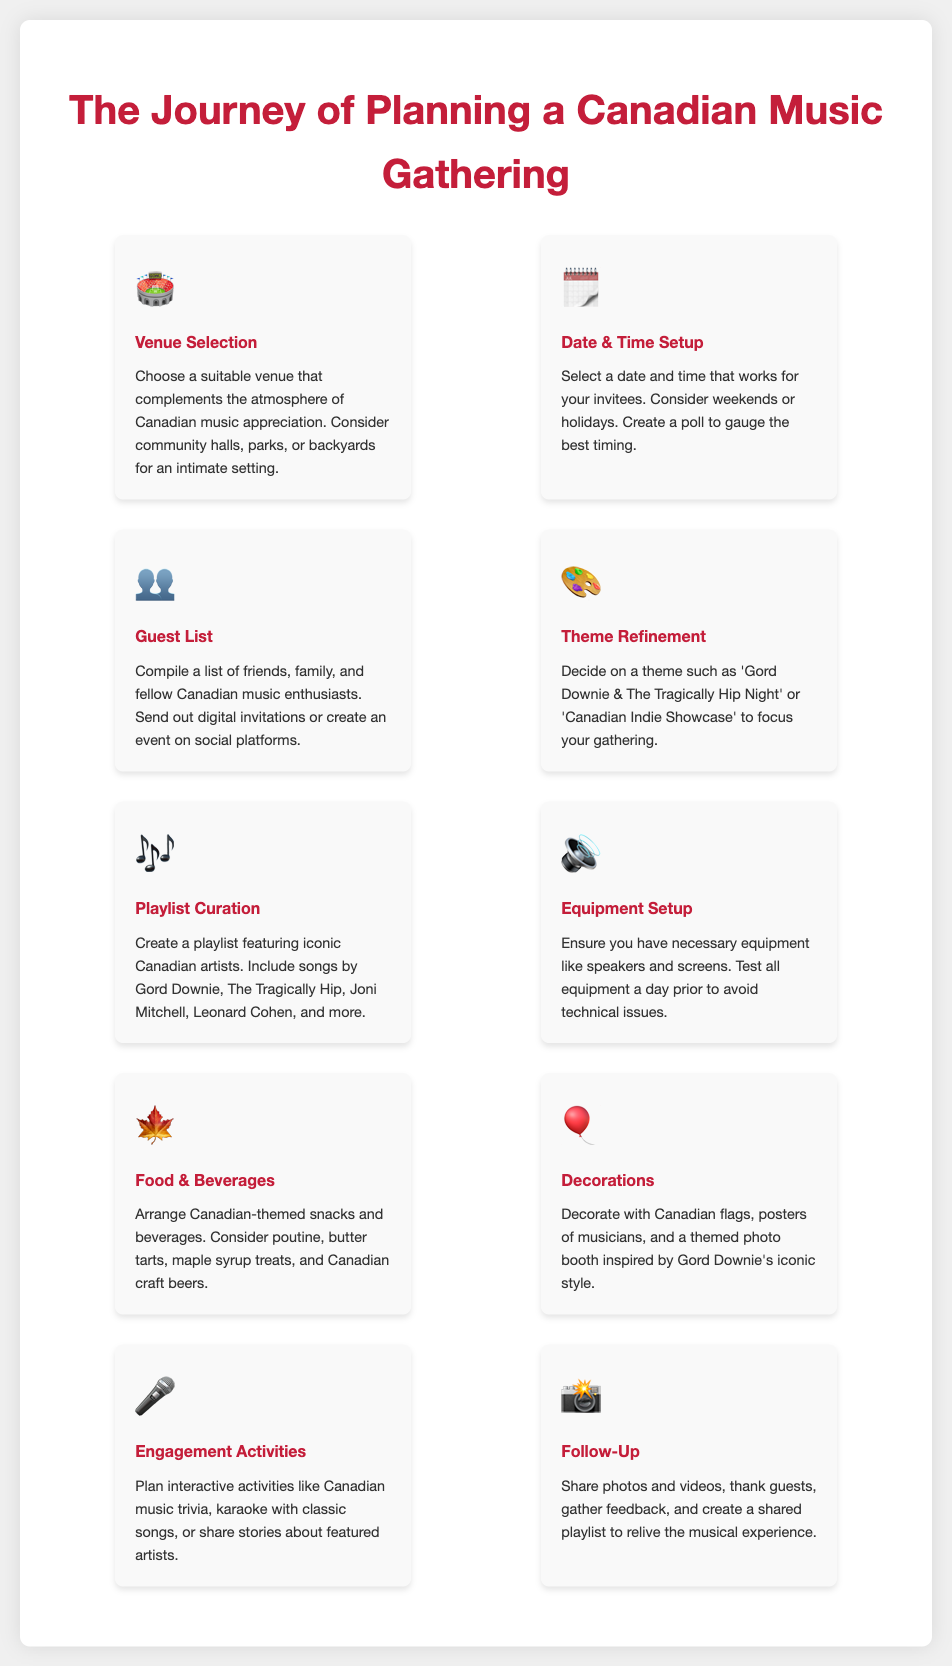what is the step that involves choosing a suitable venue? The step that involves choosing a suitable venue is labeled as "Venue Selection" in the document.
Answer: Venue Selection which Canadian-themed snack is mentioned for the food arrangement? The document mentions "poutine" as one of the Canadian-themed snacks in the food arrangement step.
Answer: poutine how many steps are listed in the process of planning a gathering? The total number of steps listed in the process is ten, as indicated in the document.
Answer: ten what is the theme refinement option focused on? The theme refinement option focuses on creating a specific theme like 'Gord Downie & The Tragically Hip Night' or 'Canadian Indie Showcase'.
Answer: 'Gord Downie & The Tragically Hip Night' or 'Canadian Indie Showcase' which step involves planning interactive activities? The step where planning interactive activities occurs is called "Engagement Activities" in the document.
Answer: Engagement Activities what is the final step called in the planning process? The final step in the planning process is labeled as "Follow-Up," which includes sharing photos and videos.
Answer: Follow-Up what is suggested for the equipment setup step? The equipment setup step suggests ensuring necessary equipment like speakers and screens, and testing them a day prior.
Answer: Ensure necessary equipment like speakers and screens what decorative element is mentioned in the document for creating a themed atmosphere? The document mentions "Canadian flags" among other things as decorative elements for creating a themed atmosphere.
Answer: Canadian flags what date and time consideration is proposed in the gathering planning? The proposed consideration for date and time setup is to select weekends or holidays for the gathering.
Answer: weekends or holidays 